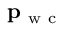Convert formula to latex. <formula><loc_0><loc_0><loc_500><loc_500>p _ { w c }</formula> 